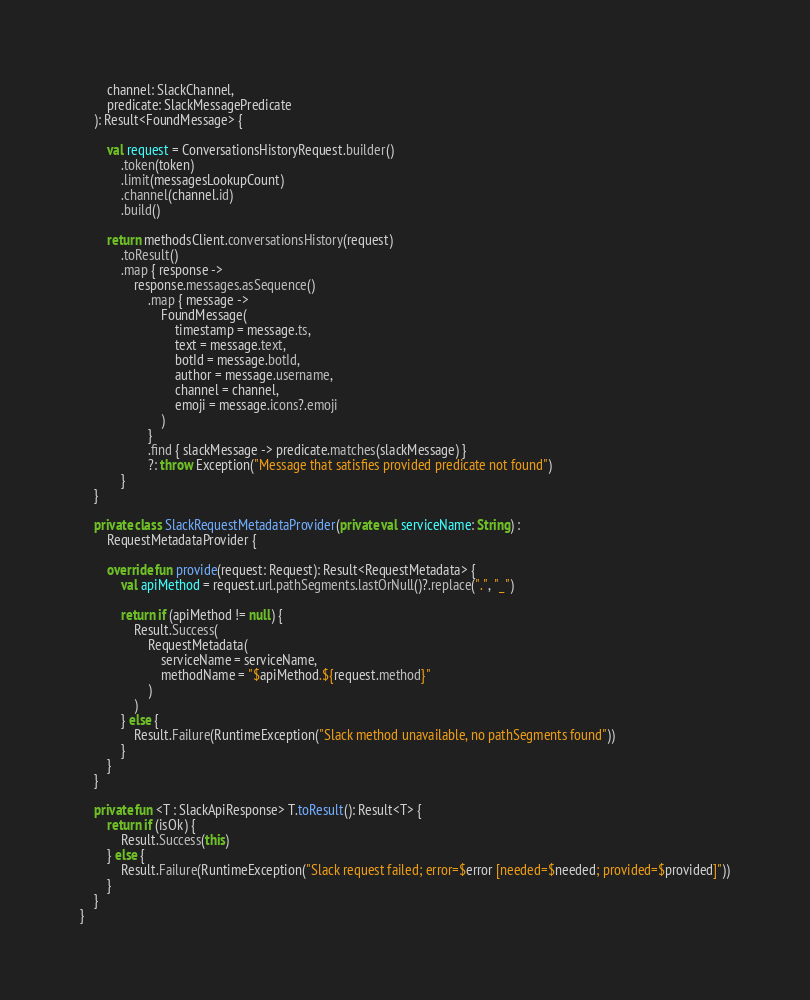<code> <loc_0><loc_0><loc_500><loc_500><_Kotlin_>        channel: SlackChannel,
        predicate: SlackMessagePredicate
    ): Result<FoundMessage> {

        val request = ConversationsHistoryRequest.builder()
            .token(token)
            .limit(messagesLookupCount)
            .channel(channel.id)
            .build()

        return methodsClient.conversationsHistory(request)
            .toResult()
            .map { response ->
                response.messages.asSequence()
                    .map { message ->
                        FoundMessage(
                            timestamp = message.ts,
                            text = message.text,
                            botId = message.botId,
                            author = message.username,
                            channel = channel,
                            emoji = message.icons?.emoji
                        )
                    }
                    .find { slackMessage -> predicate.matches(slackMessage) }
                    ?: throw Exception("Message that satisfies provided predicate not found")
            }
    }

    private class SlackRequestMetadataProvider(private val serviceName: String) :
        RequestMetadataProvider {

        override fun provide(request: Request): Result<RequestMetadata> {
            val apiMethod = request.url.pathSegments.lastOrNull()?.replace(".", "_")

            return if (apiMethod != null) {
                Result.Success(
                    RequestMetadata(
                        serviceName = serviceName,
                        methodName = "$apiMethod.${request.method}"
                    )
                )
            } else {
                Result.Failure(RuntimeException("Slack method unavailable, no pathSegments found"))
            }
        }
    }

    private fun <T : SlackApiResponse> T.toResult(): Result<T> {
        return if (isOk) {
            Result.Success(this)
        } else {
            Result.Failure(RuntimeException("Slack request failed; error=$error [needed=$needed; provided=$provided]"))
        }
    }
}
</code> 